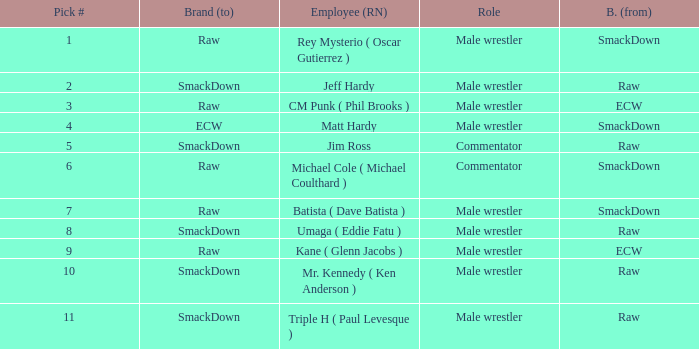What role did Pick # 10 have? Male wrestler. 